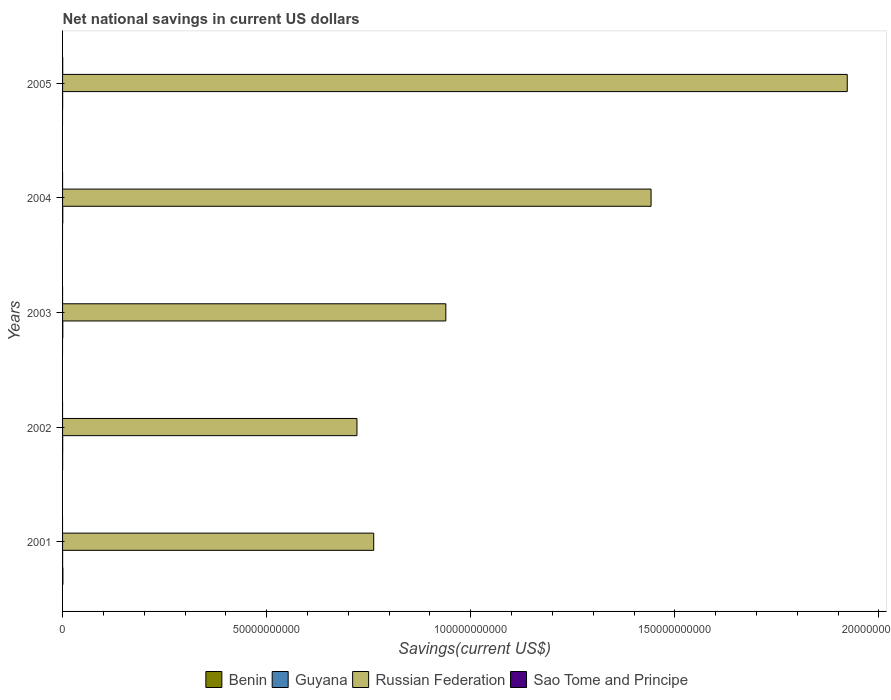Are the number of bars per tick equal to the number of legend labels?
Provide a short and direct response. No. Are the number of bars on each tick of the Y-axis equal?
Your response must be concise. No. How many bars are there on the 1st tick from the top?
Offer a very short reply. 3. What is the label of the 1st group of bars from the top?
Ensure brevity in your answer.  2005. Across all years, what is the maximum net national savings in Guyana?
Ensure brevity in your answer.  5.83e+07. In which year was the net national savings in Russian Federation maximum?
Offer a very short reply. 2005. What is the total net national savings in Guyana in the graph?
Give a very brief answer. 1.70e+08. What is the difference between the net national savings in Russian Federation in 2002 and that in 2003?
Your response must be concise. -2.18e+1. What is the difference between the net national savings in Benin in 2005 and the net national savings in Russian Federation in 2002?
Your response must be concise. -7.21e+1. What is the average net national savings in Sao Tome and Principe per year?
Ensure brevity in your answer.  7.83e+06. In the year 2005, what is the difference between the net national savings in Russian Federation and net national savings in Guyana?
Make the answer very short. 1.92e+11. What is the ratio of the net national savings in Russian Federation in 2002 to that in 2003?
Offer a terse response. 0.77. Is the net national savings in Russian Federation in 2002 less than that in 2005?
Give a very brief answer. Yes. What is the difference between the highest and the second highest net national savings in Guyana?
Ensure brevity in your answer.  4.30e+06. What is the difference between the highest and the lowest net national savings in Benin?
Your answer should be compact. 8.32e+07. In how many years, is the net national savings in Sao Tome and Principe greater than the average net national savings in Sao Tome and Principe taken over all years?
Offer a very short reply. 1. Is it the case that in every year, the sum of the net national savings in Benin and net national savings in Guyana is greater than the sum of net national savings in Russian Federation and net national savings in Sao Tome and Principe?
Make the answer very short. No. Is it the case that in every year, the sum of the net national savings in Guyana and net national savings in Sao Tome and Principe is greater than the net national savings in Russian Federation?
Provide a short and direct response. No. Are all the bars in the graph horizontal?
Provide a short and direct response. Yes. How many years are there in the graph?
Your answer should be very brief. 5. Where does the legend appear in the graph?
Provide a short and direct response. Bottom center. What is the title of the graph?
Offer a terse response. Net national savings in current US dollars. What is the label or title of the X-axis?
Provide a short and direct response. Savings(current US$). What is the label or title of the Y-axis?
Your response must be concise. Years. What is the Savings(current US$) of Benin in 2001?
Provide a succinct answer. 8.32e+07. What is the Savings(current US$) in Guyana in 2001?
Your answer should be very brief. 1.03e+07. What is the Savings(current US$) in Russian Federation in 2001?
Keep it short and to the point. 7.62e+1. What is the Savings(current US$) of Benin in 2002?
Your response must be concise. 9.21e+06. What is the Savings(current US$) of Guyana in 2002?
Provide a short and direct response. 2.97e+07. What is the Savings(current US$) in Russian Federation in 2002?
Ensure brevity in your answer.  7.21e+1. What is the Savings(current US$) in Sao Tome and Principe in 2002?
Make the answer very short. 0. What is the Savings(current US$) in Guyana in 2003?
Your answer should be compact. 5.83e+07. What is the Savings(current US$) in Russian Federation in 2003?
Your response must be concise. 9.39e+1. What is the Savings(current US$) in Sao Tome and Principe in 2003?
Your answer should be very brief. 7.44e+05. What is the Savings(current US$) of Benin in 2004?
Ensure brevity in your answer.  0. What is the Savings(current US$) of Guyana in 2004?
Ensure brevity in your answer.  5.40e+07. What is the Savings(current US$) of Russian Federation in 2004?
Give a very brief answer. 1.44e+11. What is the Savings(current US$) of Benin in 2005?
Your response must be concise. 0. What is the Savings(current US$) in Guyana in 2005?
Provide a short and direct response. 1.76e+07. What is the Savings(current US$) of Russian Federation in 2005?
Offer a terse response. 1.92e+11. What is the Savings(current US$) of Sao Tome and Principe in 2005?
Keep it short and to the point. 3.84e+07. Across all years, what is the maximum Savings(current US$) of Benin?
Give a very brief answer. 8.32e+07. Across all years, what is the maximum Savings(current US$) in Guyana?
Provide a succinct answer. 5.83e+07. Across all years, what is the maximum Savings(current US$) in Russian Federation?
Your answer should be compact. 1.92e+11. Across all years, what is the maximum Savings(current US$) in Sao Tome and Principe?
Provide a succinct answer. 3.84e+07. Across all years, what is the minimum Savings(current US$) in Benin?
Your response must be concise. 0. Across all years, what is the minimum Savings(current US$) in Guyana?
Make the answer very short. 1.03e+07. Across all years, what is the minimum Savings(current US$) of Russian Federation?
Your answer should be very brief. 7.21e+1. What is the total Savings(current US$) of Benin in the graph?
Provide a short and direct response. 9.24e+07. What is the total Savings(current US$) in Guyana in the graph?
Give a very brief answer. 1.70e+08. What is the total Savings(current US$) in Russian Federation in the graph?
Give a very brief answer. 5.79e+11. What is the total Savings(current US$) of Sao Tome and Principe in the graph?
Your answer should be compact. 3.91e+07. What is the difference between the Savings(current US$) of Benin in 2001 and that in 2002?
Provide a short and direct response. 7.40e+07. What is the difference between the Savings(current US$) in Guyana in 2001 and that in 2002?
Your response must be concise. -1.94e+07. What is the difference between the Savings(current US$) of Russian Federation in 2001 and that in 2002?
Provide a short and direct response. 4.11e+09. What is the difference between the Savings(current US$) of Guyana in 2001 and that in 2003?
Provide a short and direct response. -4.81e+07. What is the difference between the Savings(current US$) of Russian Federation in 2001 and that in 2003?
Provide a succinct answer. -1.77e+1. What is the difference between the Savings(current US$) in Guyana in 2001 and that in 2004?
Your answer should be compact. -4.38e+07. What is the difference between the Savings(current US$) in Russian Federation in 2001 and that in 2004?
Provide a succinct answer. -6.79e+1. What is the difference between the Savings(current US$) in Guyana in 2001 and that in 2005?
Offer a very short reply. -7.37e+06. What is the difference between the Savings(current US$) in Russian Federation in 2001 and that in 2005?
Offer a very short reply. -1.16e+11. What is the difference between the Savings(current US$) of Guyana in 2002 and that in 2003?
Your response must be concise. -2.86e+07. What is the difference between the Savings(current US$) in Russian Federation in 2002 and that in 2003?
Provide a succinct answer. -2.18e+1. What is the difference between the Savings(current US$) in Guyana in 2002 and that in 2004?
Give a very brief answer. -2.43e+07. What is the difference between the Savings(current US$) in Russian Federation in 2002 and that in 2004?
Provide a short and direct response. -7.21e+1. What is the difference between the Savings(current US$) in Guyana in 2002 and that in 2005?
Keep it short and to the point. 1.21e+07. What is the difference between the Savings(current US$) in Russian Federation in 2002 and that in 2005?
Provide a succinct answer. -1.20e+11. What is the difference between the Savings(current US$) in Guyana in 2003 and that in 2004?
Make the answer very short. 4.30e+06. What is the difference between the Savings(current US$) in Russian Federation in 2003 and that in 2004?
Offer a terse response. -5.03e+1. What is the difference between the Savings(current US$) of Guyana in 2003 and that in 2005?
Offer a very short reply. 4.07e+07. What is the difference between the Savings(current US$) of Russian Federation in 2003 and that in 2005?
Provide a short and direct response. -9.83e+1. What is the difference between the Savings(current US$) of Sao Tome and Principe in 2003 and that in 2005?
Offer a very short reply. -3.76e+07. What is the difference between the Savings(current US$) of Guyana in 2004 and that in 2005?
Your answer should be compact. 3.64e+07. What is the difference between the Savings(current US$) in Russian Federation in 2004 and that in 2005?
Provide a succinct answer. -4.81e+1. What is the difference between the Savings(current US$) in Benin in 2001 and the Savings(current US$) in Guyana in 2002?
Offer a terse response. 5.35e+07. What is the difference between the Savings(current US$) in Benin in 2001 and the Savings(current US$) in Russian Federation in 2002?
Your answer should be compact. -7.20e+1. What is the difference between the Savings(current US$) of Guyana in 2001 and the Savings(current US$) of Russian Federation in 2002?
Your answer should be compact. -7.21e+1. What is the difference between the Savings(current US$) of Benin in 2001 and the Savings(current US$) of Guyana in 2003?
Give a very brief answer. 2.48e+07. What is the difference between the Savings(current US$) in Benin in 2001 and the Savings(current US$) in Russian Federation in 2003?
Your answer should be very brief. -9.38e+1. What is the difference between the Savings(current US$) in Benin in 2001 and the Savings(current US$) in Sao Tome and Principe in 2003?
Your answer should be very brief. 8.24e+07. What is the difference between the Savings(current US$) in Guyana in 2001 and the Savings(current US$) in Russian Federation in 2003?
Make the answer very short. -9.39e+1. What is the difference between the Savings(current US$) of Guyana in 2001 and the Savings(current US$) of Sao Tome and Principe in 2003?
Give a very brief answer. 9.52e+06. What is the difference between the Savings(current US$) of Russian Federation in 2001 and the Savings(current US$) of Sao Tome and Principe in 2003?
Your answer should be compact. 7.62e+1. What is the difference between the Savings(current US$) in Benin in 2001 and the Savings(current US$) in Guyana in 2004?
Your response must be concise. 2.91e+07. What is the difference between the Savings(current US$) in Benin in 2001 and the Savings(current US$) in Russian Federation in 2004?
Offer a terse response. -1.44e+11. What is the difference between the Savings(current US$) of Guyana in 2001 and the Savings(current US$) of Russian Federation in 2004?
Keep it short and to the point. -1.44e+11. What is the difference between the Savings(current US$) of Benin in 2001 and the Savings(current US$) of Guyana in 2005?
Offer a very short reply. 6.56e+07. What is the difference between the Savings(current US$) in Benin in 2001 and the Savings(current US$) in Russian Federation in 2005?
Offer a terse response. -1.92e+11. What is the difference between the Savings(current US$) of Benin in 2001 and the Savings(current US$) of Sao Tome and Principe in 2005?
Provide a succinct answer. 4.48e+07. What is the difference between the Savings(current US$) in Guyana in 2001 and the Savings(current US$) in Russian Federation in 2005?
Your answer should be compact. -1.92e+11. What is the difference between the Savings(current US$) in Guyana in 2001 and the Savings(current US$) in Sao Tome and Principe in 2005?
Ensure brevity in your answer.  -2.81e+07. What is the difference between the Savings(current US$) of Russian Federation in 2001 and the Savings(current US$) of Sao Tome and Principe in 2005?
Make the answer very short. 7.62e+1. What is the difference between the Savings(current US$) in Benin in 2002 and the Savings(current US$) in Guyana in 2003?
Offer a terse response. -4.91e+07. What is the difference between the Savings(current US$) of Benin in 2002 and the Savings(current US$) of Russian Federation in 2003?
Provide a succinct answer. -9.39e+1. What is the difference between the Savings(current US$) of Benin in 2002 and the Savings(current US$) of Sao Tome and Principe in 2003?
Your response must be concise. 8.46e+06. What is the difference between the Savings(current US$) in Guyana in 2002 and the Savings(current US$) in Russian Federation in 2003?
Offer a terse response. -9.39e+1. What is the difference between the Savings(current US$) in Guyana in 2002 and the Savings(current US$) in Sao Tome and Principe in 2003?
Your answer should be compact. 2.90e+07. What is the difference between the Savings(current US$) in Russian Federation in 2002 and the Savings(current US$) in Sao Tome and Principe in 2003?
Your answer should be compact. 7.21e+1. What is the difference between the Savings(current US$) of Benin in 2002 and the Savings(current US$) of Guyana in 2004?
Give a very brief answer. -4.48e+07. What is the difference between the Savings(current US$) of Benin in 2002 and the Savings(current US$) of Russian Federation in 2004?
Your answer should be compact. -1.44e+11. What is the difference between the Savings(current US$) in Guyana in 2002 and the Savings(current US$) in Russian Federation in 2004?
Make the answer very short. -1.44e+11. What is the difference between the Savings(current US$) of Benin in 2002 and the Savings(current US$) of Guyana in 2005?
Offer a very short reply. -8.43e+06. What is the difference between the Savings(current US$) in Benin in 2002 and the Savings(current US$) in Russian Federation in 2005?
Your answer should be very brief. -1.92e+11. What is the difference between the Savings(current US$) of Benin in 2002 and the Savings(current US$) of Sao Tome and Principe in 2005?
Offer a very short reply. -2.92e+07. What is the difference between the Savings(current US$) in Guyana in 2002 and the Savings(current US$) in Russian Federation in 2005?
Make the answer very short. -1.92e+11. What is the difference between the Savings(current US$) of Guyana in 2002 and the Savings(current US$) of Sao Tome and Principe in 2005?
Make the answer very short. -8.67e+06. What is the difference between the Savings(current US$) of Russian Federation in 2002 and the Savings(current US$) of Sao Tome and Principe in 2005?
Your response must be concise. 7.21e+1. What is the difference between the Savings(current US$) of Guyana in 2003 and the Savings(current US$) of Russian Federation in 2004?
Your response must be concise. -1.44e+11. What is the difference between the Savings(current US$) of Guyana in 2003 and the Savings(current US$) of Russian Federation in 2005?
Ensure brevity in your answer.  -1.92e+11. What is the difference between the Savings(current US$) of Guyana in 2003 and the Savings(current US$) of Sao Tome and Principe in 2005?
Ensure brevity in your answer.  2.00e+07. What is the difference between the Savings(current US$) in Russian Federation in 2003 and the Savings(current US$) in Sao Tome and Principe in 2005?
Your answer should be very brief. 9.39e+1. What is the difference between the Savings(current US$) of Guyana in 2004 and the Savings(current US$) of Russian Federation in 2005?
Offer a terse response. -1.92e+11. What is the difference between the Savings(current US$) in Guyana in 2004 and the Savings(current US$) in Sao Tome and Principe in 2005?
Your answer should be compact. 1.57e+07. What is the difference between the Savings(current US$) in Russian Federation in 2004 and the Savings(current US$) in Sao Tome and Principe in 2005?
Your response must be concise. 1.44e+11. What is the average Savings(current US$) in Benin per year?
Offer a terse response. 1.85e+07. What is the average Savings(current US$) of Guyana per year?
Provide a succinct answer. 3.40e+07. What is the average Savings(current US$) in Russian Federation per year?
Provide a short and direct response. 1.16e+11. What is the average Savings(current US$) of Sao Tome and Principe per year?
Ensure brevity in your answer.  7.83e+06. In the year 2001, what is the difference between the Savings(current US$) of Benin and Savings(current US$) of Guyana?
Give a very brief answer. 7.29e+07. In the year 2001, what is the difference between the Savings(current US$) in Benin and Savings(current US$) in Russian Federation?
Make the answer very short. -7.61e+1. In the year 2001, what is the difference between the Savings(current US$) in Guyana and Savings(current US$) in Russian Federation?
Offer a very short reply. -7.62e+1. In the year 2002, what is the difference between the Savings(current US$) in Benin and Savings(current US$) in Guyana?
Your response must be concise. -2.05e+07. In the year 2002, what is the difference between the Savings(current US$) of Benin and Savings(current US$) of Russian Federation?
Your answer should be compact. -7.21e+1. In the year 2002, what is the difference between the Savings(current US$) of Guyana and Savings(current US$) of Russian Federation?
Offer a very short reply. -7.21e+1. In the year 2003, what is the difference between the Savings(current US$) in Guyana and Savings(current US$) in Russian Federation?
Your answer should be very brief. -9.38e+1. In the year 2003, what is the difference between the Savings(current US$) in Guyana and Savings(current US$) in Sao Tome and Principe?
Offer a very short reply. 5.76e+07. In the year 2003, what is the difference between the Savings(current US$) in Russian Federation and Savings(current US$) in Sao Tome and Principe?
Give a very brief answer. 9.39e+1. In the year 2004, what is the difference between the Savings(current US$) of Guyana and Savings(current US$) of Russian Federation?
Ensure brevity in your answer.  -1.44e+11. In the year 2005, what is the difference between the Savings(current US$) of Guyana and Savings(current US$) of Russian Federation?
Offer a very short reply. -1.92e+11. In the year 2005, what is the difference between the Savings(current US$) in Guyana and Savings(current US$) in Sao Tome and Principe?
Your response must be concise. -2.08e+07. In the year 2005, what is the difference between the Savings(current US$) of Russian Federation and Savings(current US$) of Sao Tome and Principe?
Your answer should be compact. 1.92e+11. What is the ratio of the Savings(current US$) of Benin in 2001 to that in 2002?
Ensure brevity in your answer.  9.04. What is the ratio of the Savings(current US$) of Guyana in 2001 to that in 2002?
Offer a terse response. 0.35. What is the ratio of the Savings(current US$) of Russian Federation in 2001 to that in 2002?
Your response must be concise. 1.06. What is the ratio of the Savings(current US$) in Guyana in 2001 to that in 2003?
Your response must be concise. 0.18. What is the ratio of the Savings(current US$) of Russian Federation in 2001 to that in 2003?
Offer a terse response. 0.81. What is the ratio of the Savings(current US$) of Guyana in 2001 to that in 2004?
Your response must be concise. 0.19. What is the ratio of the Savings(current US$) of Russian Federation in 2001 to that in 2004?
Keep it short and to the point. 0.53. What is the ratio of the Savings(current US$) in Guyana in 2001 to that in 2005?
Give a very brief answer. 0.58. What is the ratio of the Savings(current US$) of Russian Federation in 2001 to that in 2005?
Offer a terse response. 0.4. What is the ratio of the Savings(current US$) in Guyana in 2002 to that in 2003?
Offer a very short reply. 0.51. What is the ratio of the Savings(current US$) of Russian Federation in 2002 to that in 2003?
Offer a very short reply. 0.77. What is the ratio of the Savings(current US$) in Guyana in 2002 to that in 2004?
Your answer should be compact. 0.55. What is the ratio of the Savings(current US$) of Russian Federation in 2002 to that in 2004?
Your answer should be very brief. 0.5. What is the ratio of the Savings(current US$) in Guyana in 2002 to that in 2005?
Provide a short and direct response. 1.68. What is the ratio of the Savings(current US$) of Russian Federation in 2002 to that in 2005?
Give a very brief answer. 0.38. What is the ratio of the Savings(current US$) of Guyana in 2003 to that in 2004?
Your answer should be compact. 1.08. What is the ratio of the Savings(current US$) in Russian Federation in 2003 to that in 2004?
Your answer should be compact. 0.65. What is the ratio of the Savings(current US$) in Guyana in 2003 to that in 2005?
Provide a short and direct response. 3.31. What is the ratio of the Savings(current US$) in Russian Federation in 2003 to that in 2005?
Give a very brief answer. 0.49. What is the ratio of the Savings(current US$) in Sao Tome and Principe in 2003 to that in 2005?
Give a very brief answer. 0.02. What is the ratio of the Savings(current US$) in Guyana in 2004 to that in 2005?
Keep it short and to the point. 3.06. What is the ratio of the Savings(current US$) in Russian Federation in 2004 to that in 2005?
Give a very brief answer. 0.75. What is the difference between the highest and the second highest Savings(current US$) in Guyana?
Keep it short and to the point. 4.30e+06. What is the difference between the highest and the second highest Savings(current US$) in Russian Federation?
Ensure brevity in your answer.  4.81e+1. What is the difference between the highest and the lowest Savings(current US$) of Benin?
Provide a succinct answer. 8.32e+07. What is the difference between the highest and the lowest Savings(current US$) of Guyana?
Give a very brief answer. 4.81e+07. What is the difference between the highest and the lowest Savings(current US$) in Russian Federation?
Give a very brief answer. 1.20e+11. What is the difference between the highest and the lowest Savings(current US$) of Sao Tome and Principe?
Provide a short and direct response. 3.84e+07. 